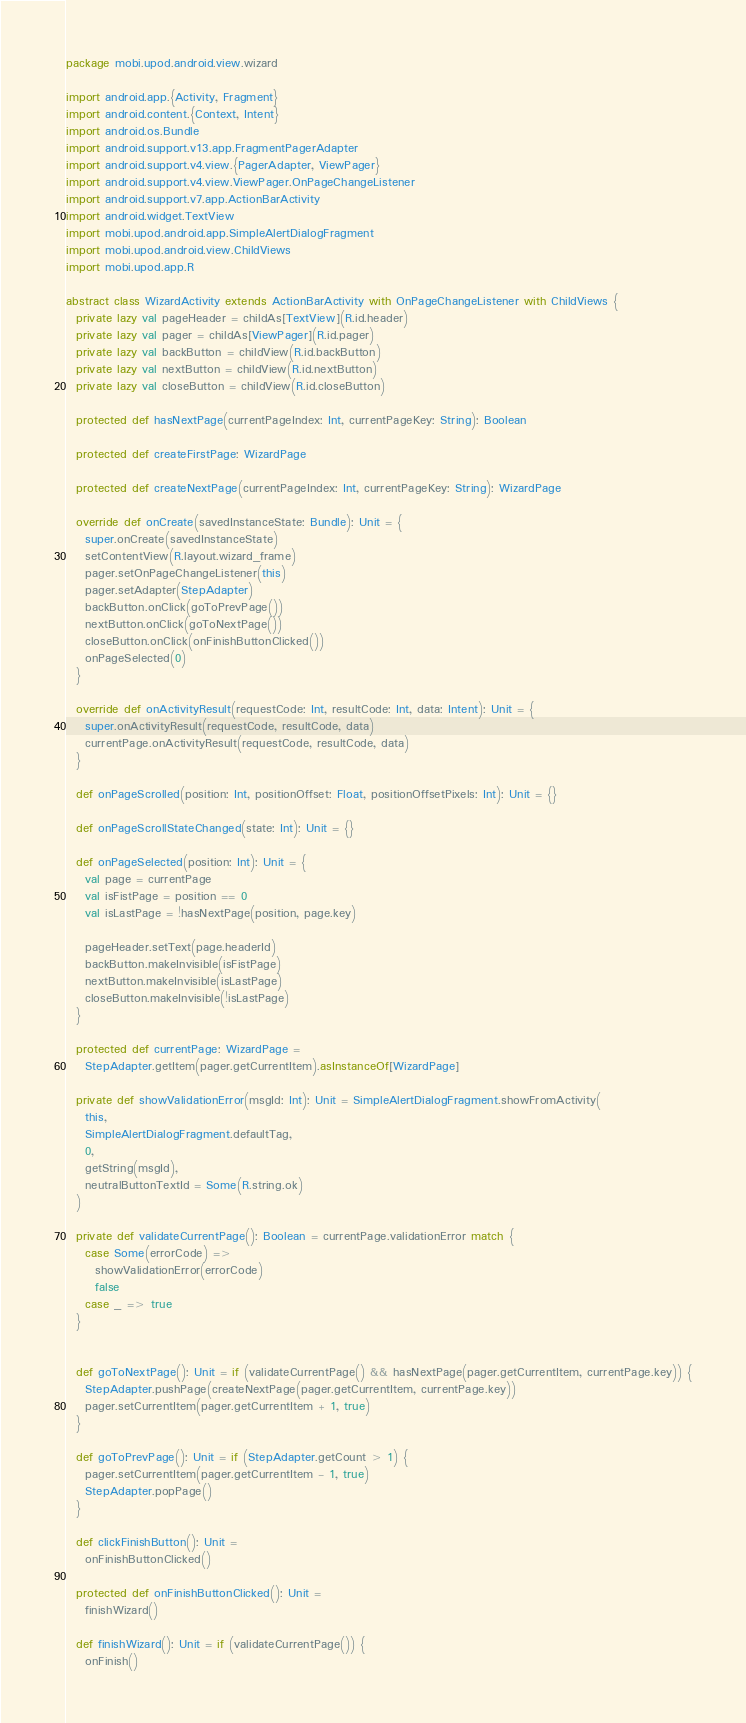Convert code to text. <code><loc_0><loc_0><loc_500><loc_500><_Scala_>package mobi.upod.android.view.wizard

import android.app.{Activity, Fragment}
import android.content.{Context, Intent}
import android.os.Bundle
import android.support.v13.app.FragmentPagerAdapter
import android.support.v4.view.{PagerAdapter, ViewPager}
import android.support.v4.view.ViewPager.OnPageChangeListener
import android.support.v7.app.ActionBarActivity
import android.widget.TextView
import mobi.upod.android.app.SimpleAlertDialogFragment
import mobi.upod.android.view.ChildViews
import mobi.upod.app.R

abstract class WizardActivity extends ActionBarActivity with OnPageChangeListener with ChildViews {
  private lazy val pageHeader = childAs[TextView](R.id.header)
  private lazy val pager = childAs[ViewPager](R.id.pager)
  private lazy val backButton = childView(R.id.backButton)
  private lazy val nextButton = childView(R.id.nextButton)
  private lazy val closeButton = childView(R.id.closeButton)

  protected def hasNextPage(currentPageIndex: Int, currentPageKey: String): Boolean

  protected def createFirstPage: WizardPage

  protected def createNextPage(currentPageIndex: Int, currentPageKey: String): WizardPage

  override def onCreate(savedInstanceState: Bundle): Unit = {
    super.onCreate(savedInstanceState)
    setContentView(R.layout.wizard_frame)
    pager.setOnPageChangeListener(this)
    pager.setAdapter(StepAdapter)
    backButton.onClick(goToPrevPage())
    nextButton.onClick(goToNextPage())
    closeButton.onClick(onFinishButtonClicked())
    onPageSelected(0)
  }

  override def onActivityResult(requestCode: Int, resultCode: Int, data: Intent): Unit = {
    super.onActivityResult(requestCode, resultCode, data)
    currentPage.onActivityResult(requestCode, resultCode, data)
  }

  def onPageScrolled(position: Int, positionOffset: Float, positionOffsetPixels: Int): Unit = {}

  def onPageScrollStateChanged(state: Int): Unit = {}

  def onPageSelected(position: Int): Unit = {
    val page = currentPage
    val isFistPage = position == 0
    val isLastPage = !hasNextPage(position, page.key)

    pageHeader.setText(page.headerId)
    backButton.makeInvisible(isFistPage)
    nextButton.makeInvisible(isLastPage)
    closeButton.makeInvisible(!isLastPage)
  }

  protected def currentPage: WizardPage =
    StepAdapter.getItem(pager.getCurrentItem).asInstanceOf[WizardPage]

  private def showValidationError(msgId: Int): Unit = SimpleAlertDialogFragment.showFromActivity(
    this,
    SimpleAlertDialogFragment.defaultTag,
    0,
    getString(msgId),
    neutralButtonTextId = Some(R.string.ok)
  )

  private def validateCurrentPage(): Boolean = currentPage.validationError match {
    case Some(errorCode) =>
      showValidationError(errorCode)
      false
    case _ => true
  }


  def goToNextPage(): Unit = if (validateCurrentPage() && hasNextPage(pager.getCurrentItem, currentPage.key)) {
    StepAdapter.pushPage(createNextPage(pager.getCurrentItem, currentPage.key))
    pager.setCurrentItem(pager.getCurrentItem + 1, true)
  }

  def goToPrevPage(): Unit = if (StepAdapter.getCount > 1) {
    pager.setCurrentItem(pager.getCurrentItem - 1, true)
    StepAdapter.popPage()
  }

  def clickFinishButton(): Unit =
    onFinishButtonClicked()

  protected def onFinishButtonClicked(): Unit =
    finishWizard()

  def finishWizard(): Unit = if (validateCurrentPage()) {
    onFinish()
</code> 